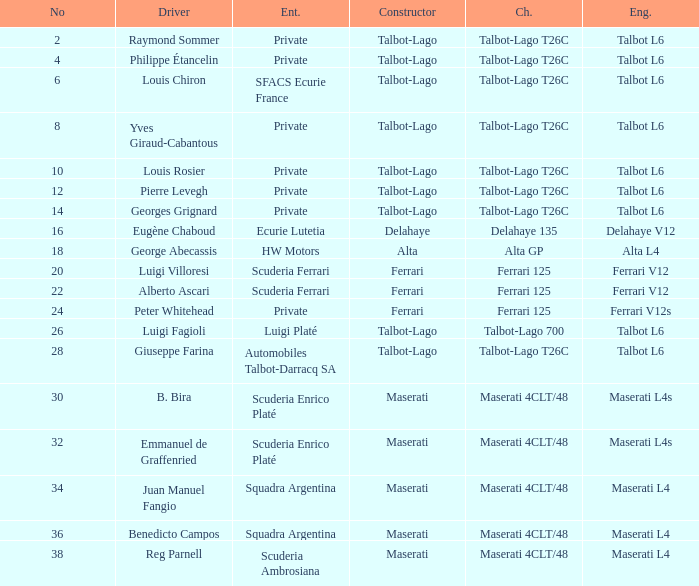Name the constructor for number 10 Talbot-Lago. 